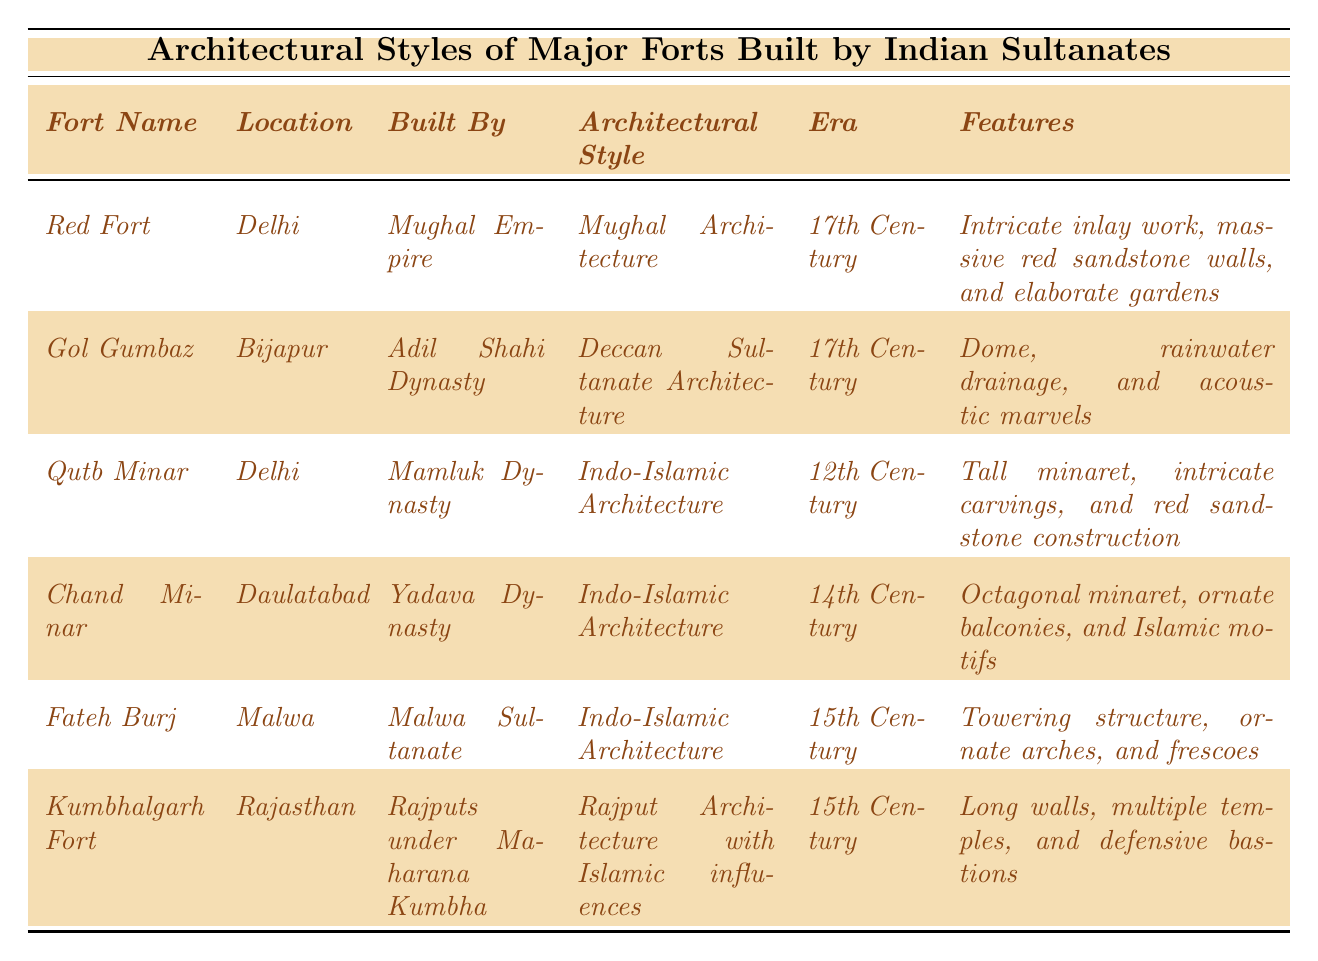What is the architectural style of the Red Fort? The table states that the architectural style of the Red Fort, built by the Mughal Empire, is Mughal Architecture.
Answer: Mughal Architecture In which century was Kumbhalgarh Fort built? According to the table, Kumbhalgarh Fort was built in the 15th Century.
Answer: 15th Century Which fort is associated with the Adil Shahi Dynasty? The table shows that Gol Gumbaz is the fort associated with the Adil Shahi Dynasty.
Answer: Gol Gumbaz Does the table indicate that the Qutb Minar was built in the 17th century? The table specifies that the Qutb Minar was built in the 12th Century, so this statement is false.
Answer: No Which architectural style is shared by Fateh Burj and Chand Minar? The table lists both Fateh Burj and Chand Minar as using Indo-Islamic Architecture.
Answer: Indo-Islamic Architecture How many forts listed in the table were built in the 15th Century? From the table, there are two forts (Fateh Burj and Kumbhalgarh Fort) that were built in the 15th Century.
Answer: 2 What are the unique features of Gol Gumbaz? The table describes Gol Gumbaz as having a dome, rainwater drainage, and acoustic marvels.
Answer: Dome, rainwater drainage, acoustic marvels Which fort has the tallest architectural feature? The Qutb Minar features the tallest structure, as it is noted as a tall minaret in the table.
Answer: Qutb Minar Which fort was built by the Rajputs under Maharana Kumbha? The table indicates that Kumbhalgarh Fort was built by the Rajputs under Maharana Kumbha.
Answer: Kumbhalgarh Fort Are there any forts listed that exhibit Islamic motifs in their architectural style? Based on the table, both Chand Minar and Fateh Burj include Islamic motifs in their features.
Answer: Yes 